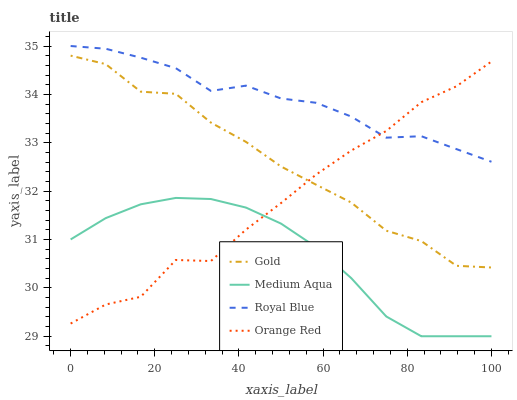Does Medium Aqua have the minimum area under the curve?
Answer yes or no. Yes. Does Royal Blue have the maximum area under the curve?
Answer yes or no. Yes. Does Orange Red have the minimum area under the curve?
Answer yes or no. No. Does Orange Red have the maximum area under the curve?
Answer yes or no. No. Is Medium Aqua the smoothest?
Answer yes or no. Yes. Is Gold the roughest?
Answer yes or no. Yes. Is Orange Red the smoothest?
Answer yes or no. No. Is Orange Red the roughest?
Answer yes or no. No. Does Medium Aqua have the lowest value?
Answer yes or no. Yes. Does Orange Red have the lowest value?
Answer yes or no. No. Does Royal Blue have the highest value?
Answer yes or no. Yes. Does Orange Red have the highest value?
Answer yes or no. No. Is Medium Aqua less than Gold?
Answer yes or no. Yes. Is Royal Blue greater than Gold?
Answer yes or no. Yes. Does Orange Red intersect Royal Blue?
Answer yes or no. Yes. Is Orange Red less than Royal Blue?
Answer yes or no. No. Is Orange Red greater than Royal Blue?
Answer yes or no. No. Does Medium Aqua intersect Gold?
Answer yes or no. No. 